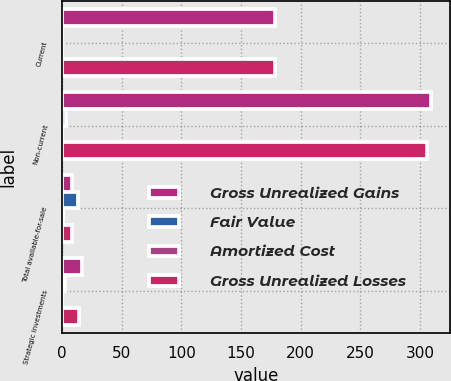Convert chart to OTSL. <chart><loc_0><loc_0><loc_500><loc_500><stacked_bar_chart><ecel><fcel>Current<fcel>Non-current<fcel>Total available-for-sale<fcel>Strategic investments<nl><fcel>Gross Unrealized Gains<fcel>178.3<fcel>309.7<fcel>8.65<fcel>16.8<nl><fcel>Fair Value<fcel>0.2<fcel>3.5<fcel>13.8<fcel>2.9<nl><fcel>Amortized Cost<fcel>0.3<fcel>0.1<fcel>1<fcel>0.1<nl><fcel>Gross Unrealized Losses<fcel>178.4<fcel>306.3<fcel>8.65<fcel>14<nl></chart> 